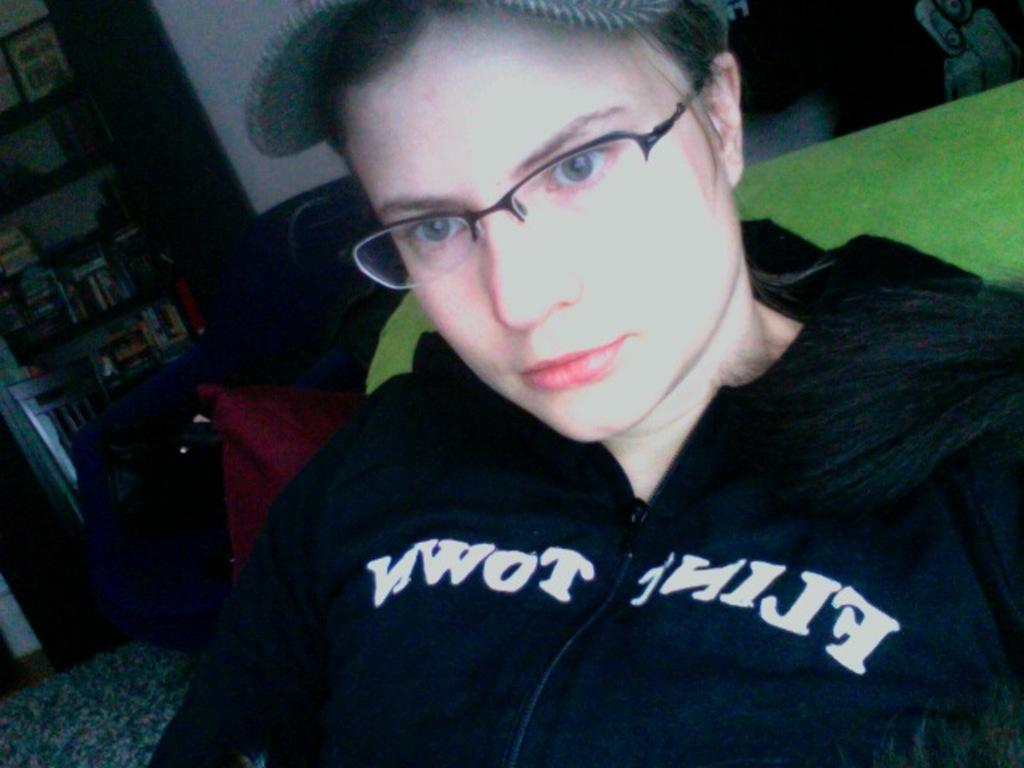What can be seen in the image? There is a person in the image. Can you describe the person's appearance? The person is wearing glasses and a cap. What can be seen in the background of the image? There are bookshelves, a table, and a chair in the background of the image. Are there any other objects visible in the background? Yes, there are other objects in the background of the image. What type of honey is the person using to make a decision in the image? There is no honey or decision-making process depicted in the image. 